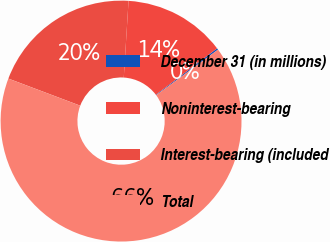Convert chart. <chart><loc_0><loc_0><loc_500><loc_500><pie_chart><fcel>December 31 (in millions)<fcel>Noninterest-bearing<fcel>Interest-bearing (included<fcel>Total<nl><fcel>0.21%<fcel>13.69%<fcel>20.25%<fcel>65.85%<nl></chart> 